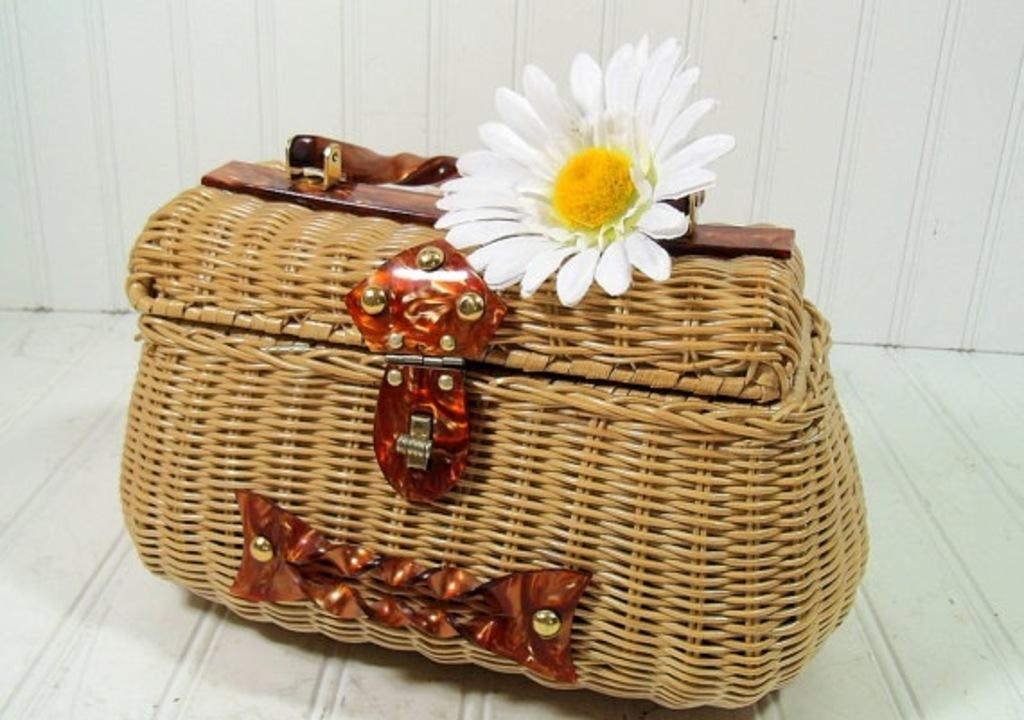What type of bag is featured in the image? There is a wooden bag in the image. What is the color of the wooden bag? The wooden bag is brown in color. What decorative element is present on the wooden bag? There is a flower on the wooden bag. What colors are the flower's petals? The flower's petals are white and yellow in color. What is the color of the background in the image? The background of the image is white. Can you see any visible veins on the wooden bag in the image? There are no veins present on the wooden bag in the image, as it is a decorative item made of wood and not a living organism. 